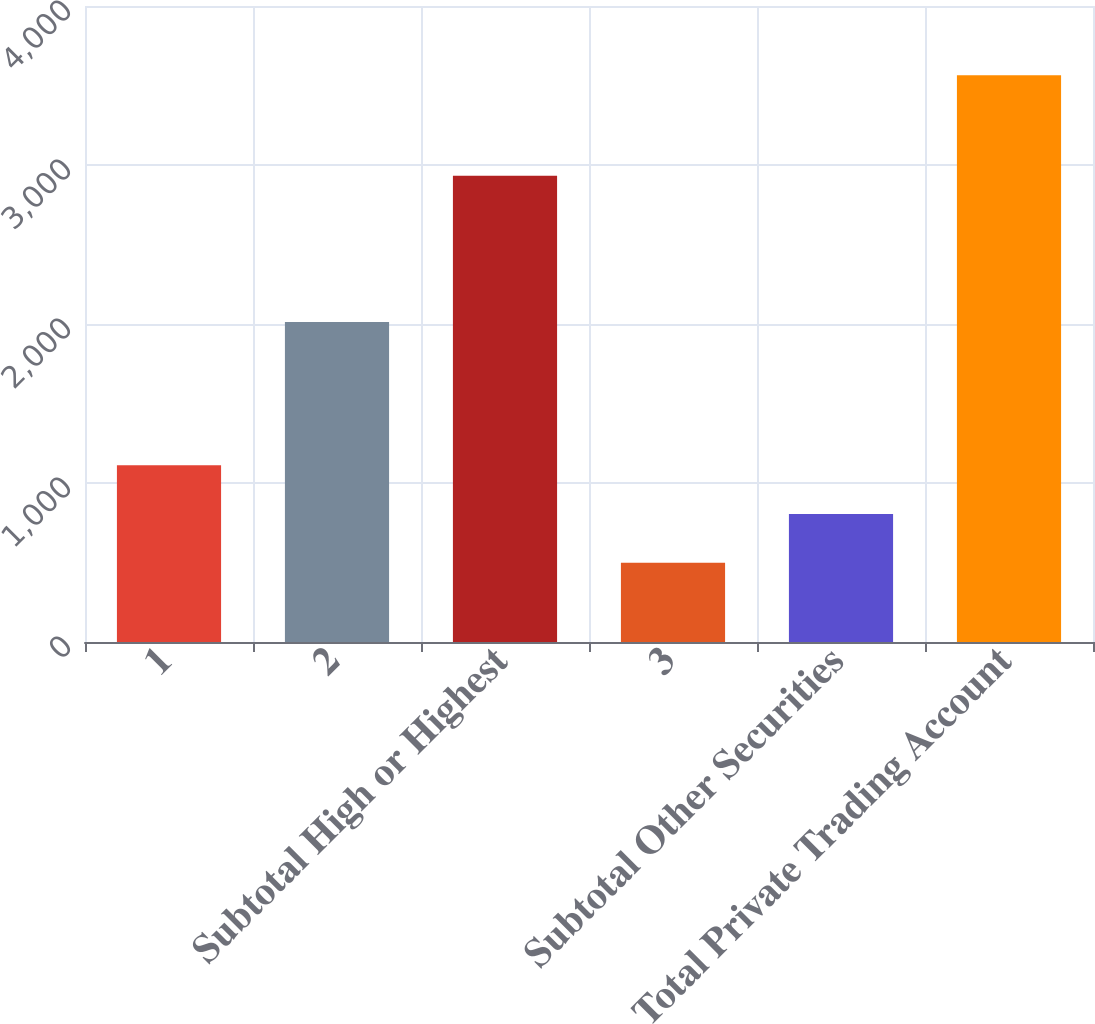<chart> <loc_0><loc_0><loc_500><loc_500><bar_chart><fcel>1<fcel>2<fcel>Subtotal High or Highest<fcel>3<fcel>Subtotal Other Securities<fcel>Total Private Trading Account<nl><fcel>1112.2<fcel>2013<fcel>2932<fcel>499<fcel>805.6<fcel>3565<nl></chart> 